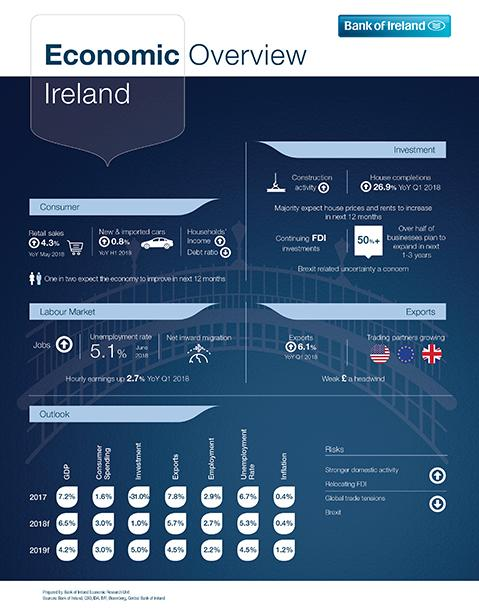Mention a couple of crucial points in this snapshot. The GDP growth of Ireland in 2017 was 0.7% while in 2018 it was -0.7%. 